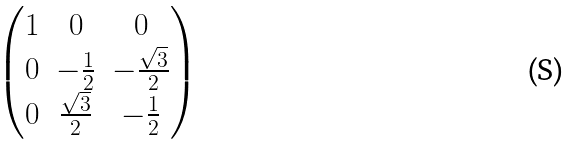Convert formula to latex. <formula><loc_0><loc_0><loc_500><loc_500>\begin{pmatrix} 1 & 0 & 0 \\ 0 & - \frac { 1 } { 2 } & - \frac { \sqrt { 3 } } { 2 } \\ 0 & \frac { \sqrt { 3 } } { 2 } & - \frac { 1 } { 2 } \end{pmatrix}</formula> 